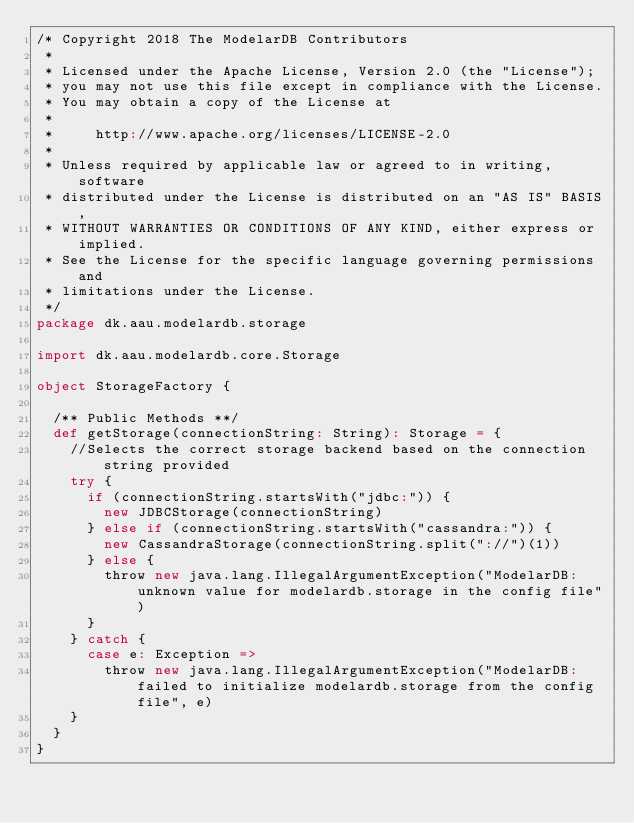Convert code to text. <code><loc_0><loc_0><loc_500><loc_500><_Scala_>/* Copyright 2018 The ModelarDB Contributors
 *
 * Licensed under the Apache License, Version 2.0 (the "License");
 * you may not use this file except in compliance with the License.
 * You may obtain a copy of the License at
 *
 *     http://www.apache.org/licenses/LICENSE-2.0
 *
 * Unless required by applicable law or agreed to in writing, software
 * distributed under the License is distributed on an "AS IS" BASIS,
 * WITHOUT WARRANTIES OR CONDITIONS OF ANY KIND, either express or implied.
 * See the License for the specific language governing permissions and
 * limitations under the License.
 */
package dk.aau.modelardb.storage

import dk.aau.modelardb.core.Storage

object StorageFactory {

  /** Public Methods **/
  def getStorage(connectionString: String): Storage = {
    //Selects the correct storage backend based on the connection string provided
    try {
      if (connectionString.startsWith("jdbc:")) {
        new JDBCStorage(connectionString)
      } else if (connectionString.startsWith("cassandra:")) {
        new CassandraStorage(connectionString.split("://")(1))
      } else {
        throw new java.lang.IllegalArgumentException("ModelarDB: unknown value for modelardb.storage in the config file")
      }
    } catch {
      case e: Exception =>
        throw new java.lang.IllegalArgumentException("ModelarDB: failed to initialize modelardb.storage from the config file", e)
    }
  }
}</code> 